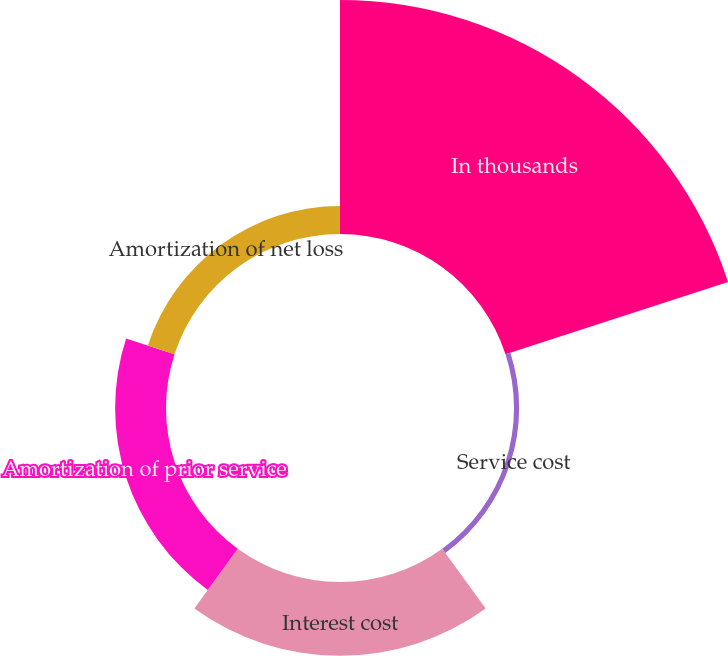<chart> <loc_0><loc_0><loc_500><loc_500><pie_chart><fcel>In thousands<fcel>Service cost<fcel>Interest cost<fcel>Amortization of prior service<fcel>Amortization of net loss<nl><fcel>59.72%<fcel>1.31%<fcel>18.83%<fcel>12.99%<fcel>7.15%<nl></chart> 